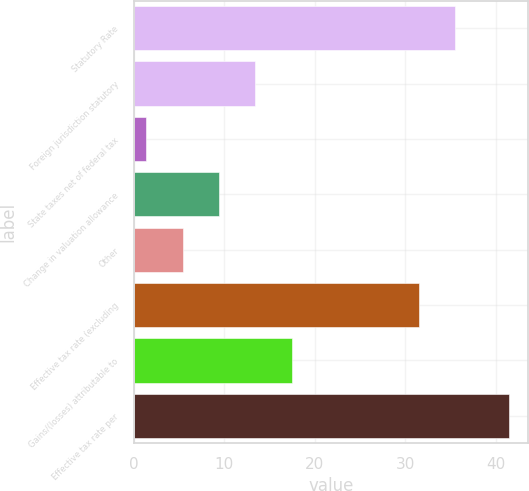Convert chart to OTSL. <chart><loc_0><loc_0><loc_500><loc_500><bar_chart><fcel>Statutory Rate<fcel>Foreign jurisdiction statutory<fcel>State taxes net of federal tax<fcel>Change in valuation allowance<fcel>Other<fcel>Effective tax rate (excluding<fcel>Gains/(losses) attributable to<fcel>Effective tax rate per<nl><fcel>35.51<fcel>13.43<fcel>1.4<fcel>9.42<fcel>5.41<fcel>31.5<fcel>17.44<fcel>41.5<nl></chart> 